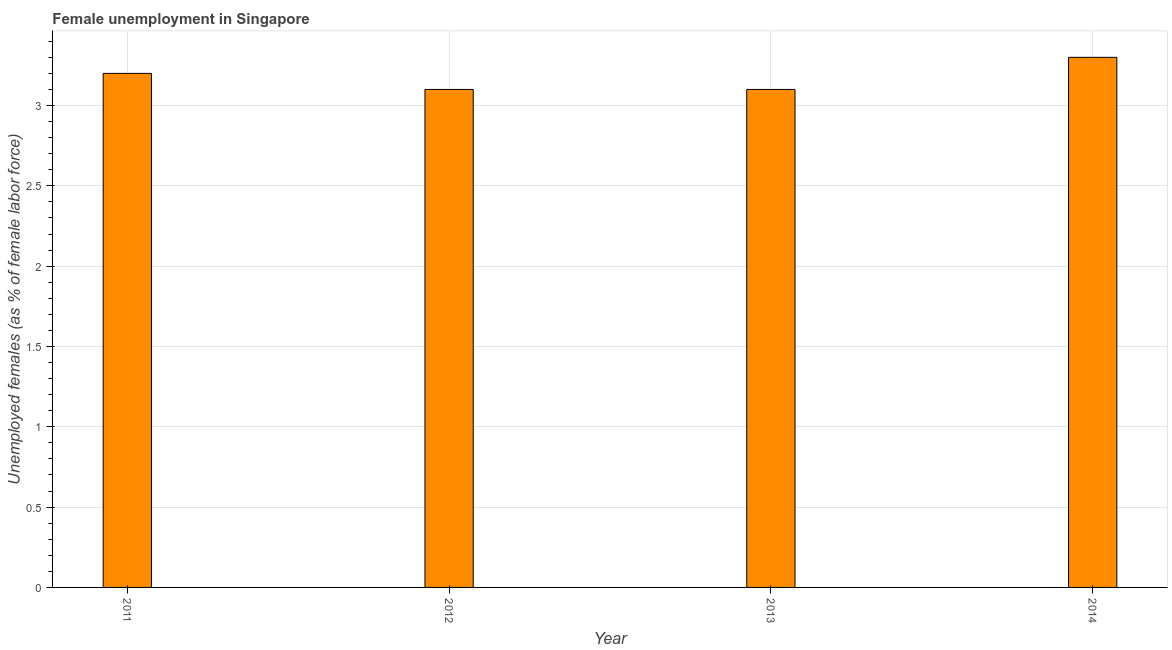Does the graph contain any zero values?
Keep it short and to the point. No. What is the title of the graph?
Keep it short and to the point. Female unemployment in Singapore. What is the label or title of the Y-axis?
Keep it short and to the point. Unemployed females (as % of female labor force). What is the unemployed females population in 2012?
Give a very brief answer. 3.1. Across all years, what is the maximum unemployed females population?
Provide a succinct answer. 3.3. Across all years, what is the minimum unemployed females population?
Offer a very short reply. 3.1. In which year was the unemployed females population minimum?
Give a very brief answer. 2012. What is the sum of the unemployed females population?
Give a very brief answer. 12.7. What is the difference between the unemployed females population in 2012 and 2014?
Keep it short and to the point. -0.2. What is the average unemployed females population per year?
Offer a very short reply. 3.17. What is the median unemployed females population?
Provide a short and direct response. 3.15. In how many years, is the unemployed females population greater than 3.2 %?
Your answer should be very brief. 2. Do a majority of the years between 2014 and 2012 (inclusive) have unemployed females population greater than 3.1 %?
Keep it short and to the point. Yes. What is the ratio of the unemployed females population in 2011 to that in 2013?
Your answer should be very brief. 1.03. Is the difference between the unemployed females population in 2013 and 2014 greater than the difference between any two years?
Offer a terse response. Yes. Is the sum of the unemployed females population in 2011 and 2012 greater than the maximum unemployed females population across all years?
Ensure brevity in your answer.  Yes. How many bars are there?
Keep it short and to the point. 4. Are all the bars in the graph horizontal?
Ensure brevity in your answer.  No. How many years are there in the graph?
Your response must be concise. 4. What is the difference between two consecutive major ticks on the Y-axis?
Offer a terse response. 0.5. What is the Unemployed females (as % of female labor force) of 2011?
Keep it short and to the point. 3.2. What is the Unemployed females (as % of female labor force) in 2012?
Your answer should be compact. 3.1. What is the Unemployed females (as % of female labor force) in 2013?
Your response must be concise. 3.1. What is the Unemployed females (as % of female labor force) of 2014?
Your answer should be very brief. 3.3. What is the difference between the Unemployed females (as % of female labor force) in 2011 and 2012?
Make the answer very short. 0.1. What is the difference between the Unemployed females (as % of female labor force) in 2011 and 2014?
Offer a terse response. -0.1. What is the difference between the Unemployed females (as % of female labor force) in 2012 and 2013?
Provide a short and direct response. 0. What is the difference between the Unemployed females (as % of female labor force) in 2013 and 2014?
Provide a short and direct response. -0.2. What is the ratio of the Unemployed females (as % of female labor force) in 2011 to that in 2012?
Ensure brevity in your answer.  1.03. What is the ratio of the Unemployed females (as % of female labor force) in 2011 to that in 2013?
Keep it short and to the point. 1.03. What is the ratio of the Unemployed females (as % of female labor force) in 2012 to that in 2014?
Offer a very short reply. 0.94. What is the ratio of the Unemployed females (as % of female labor force) in 2013 to that in 2014?
Offer a terse response. 0.94. 